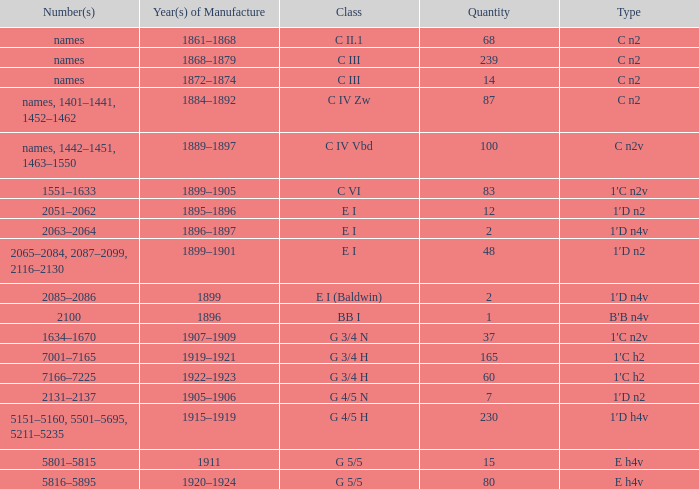Which Year(s) of Manufacture has a Quantity larger than 60, and a Number(s) of 7001–7165? 1919–1921. 